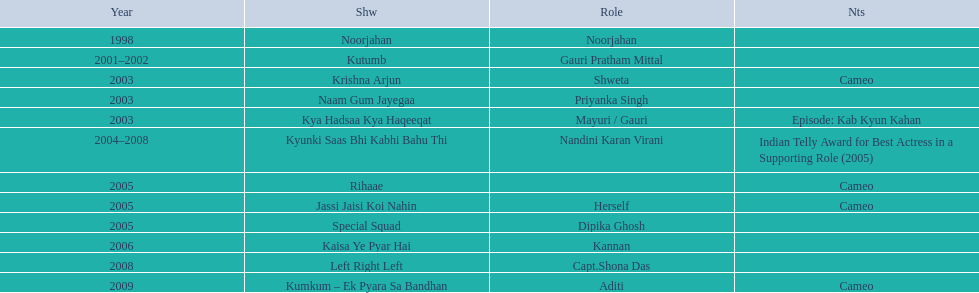Write the full table. {'header': ['Year', 'Shw', 'Role', 'Nts'], 'rows': [['1998', 'Noorjahan', 'Noorjahan', ''], ['2001–2002', 'Kutumb', 'Gauri Pratham Mittal', ''], ['2003', 'Krishna Arjun', 'Shweta', 'Cameo'], ['2003', 'Naam Gum Jayegaa', 'Priyanka Singh', ''], ['2003', 'Kya Hadsaa Kya Haqeeqat', 'Mayuri / Gauri', 'Episode: Kab Kyun Kahan'], ['2004–2008', 'Kyunki Saas Bhi Kabhi Bahu Thi', 'Nandini Karan Virani', 'Indian Telly Award for Best Actress in a Supporting Role (2005)'], ['2005', 'Rihaae', '', 'Cameo'], ['2005', 'Jassi Jaisi Koi Nahin', 'Herself', 'Cameo'], ['2005', 'Special Squad', 'Dipika Ghosh', ''], ['2006', 'Kaisa Ye Pyar Hai', 'Kannan', ''], ['2008', 'Left Right Left', 'Capt.Shona Das', ''], ['2009', 'Kumkum – Ek Pyara Sa Bandhan', 'Aditi', 'Cameo']]} In 1998 what was the role of gauri pradhan tejwani? Noorjahan. In 2003 what show did gauri have a cameo in? Krishna Arjun. Gauri was apart of which television show for the longest? Kyunki Saas Bhi Kabhi Bahu Thi. 